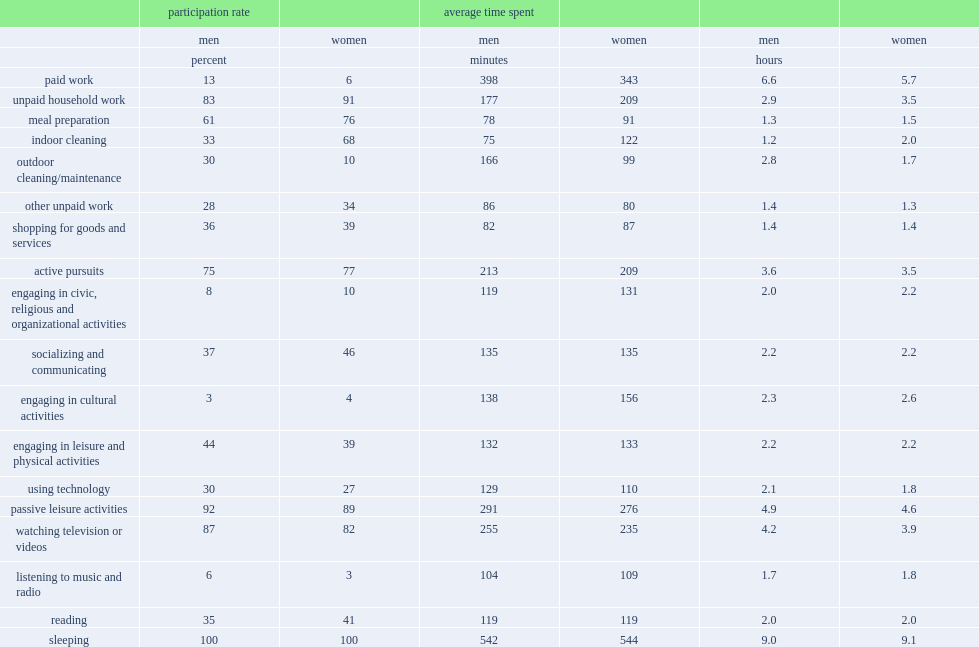What were the participation rates of unpaid household work for senior women and for senior men respectively? 91.0 83.0. Who are more likely to do some indoor cleaning during the day,senior women or men? Women. Who are more likely to participate in outdoor cleaning/maintenance,senior men or women? Men. How many minutes do senior men spent more than women when doing outdoor work? 67. Who were more likely to engage in leisure and physical activities,senior men or women? Men. Who were more likely to read,senior men or women? Women. Who spend less time on watching television,senior men or women? Women. 